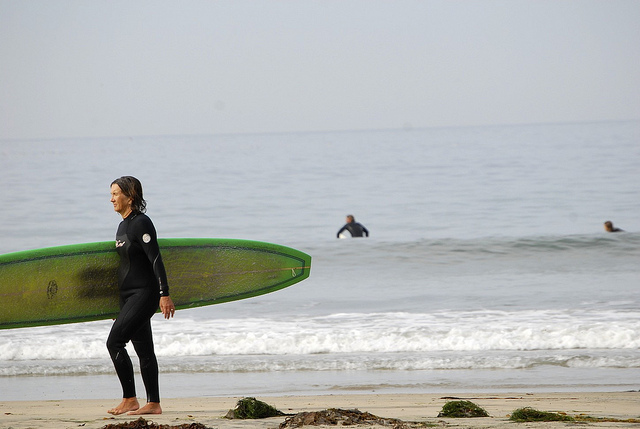What is the main activity depicted in the image? The main activity depicted in the image is surfing. This is evidenced by the presence of individuals in wetsuits, carrying surfboards, and being at a beach location with waves in the background. Surfing involves riding waves, and the people are either preparing to start or have just finished surfing. 